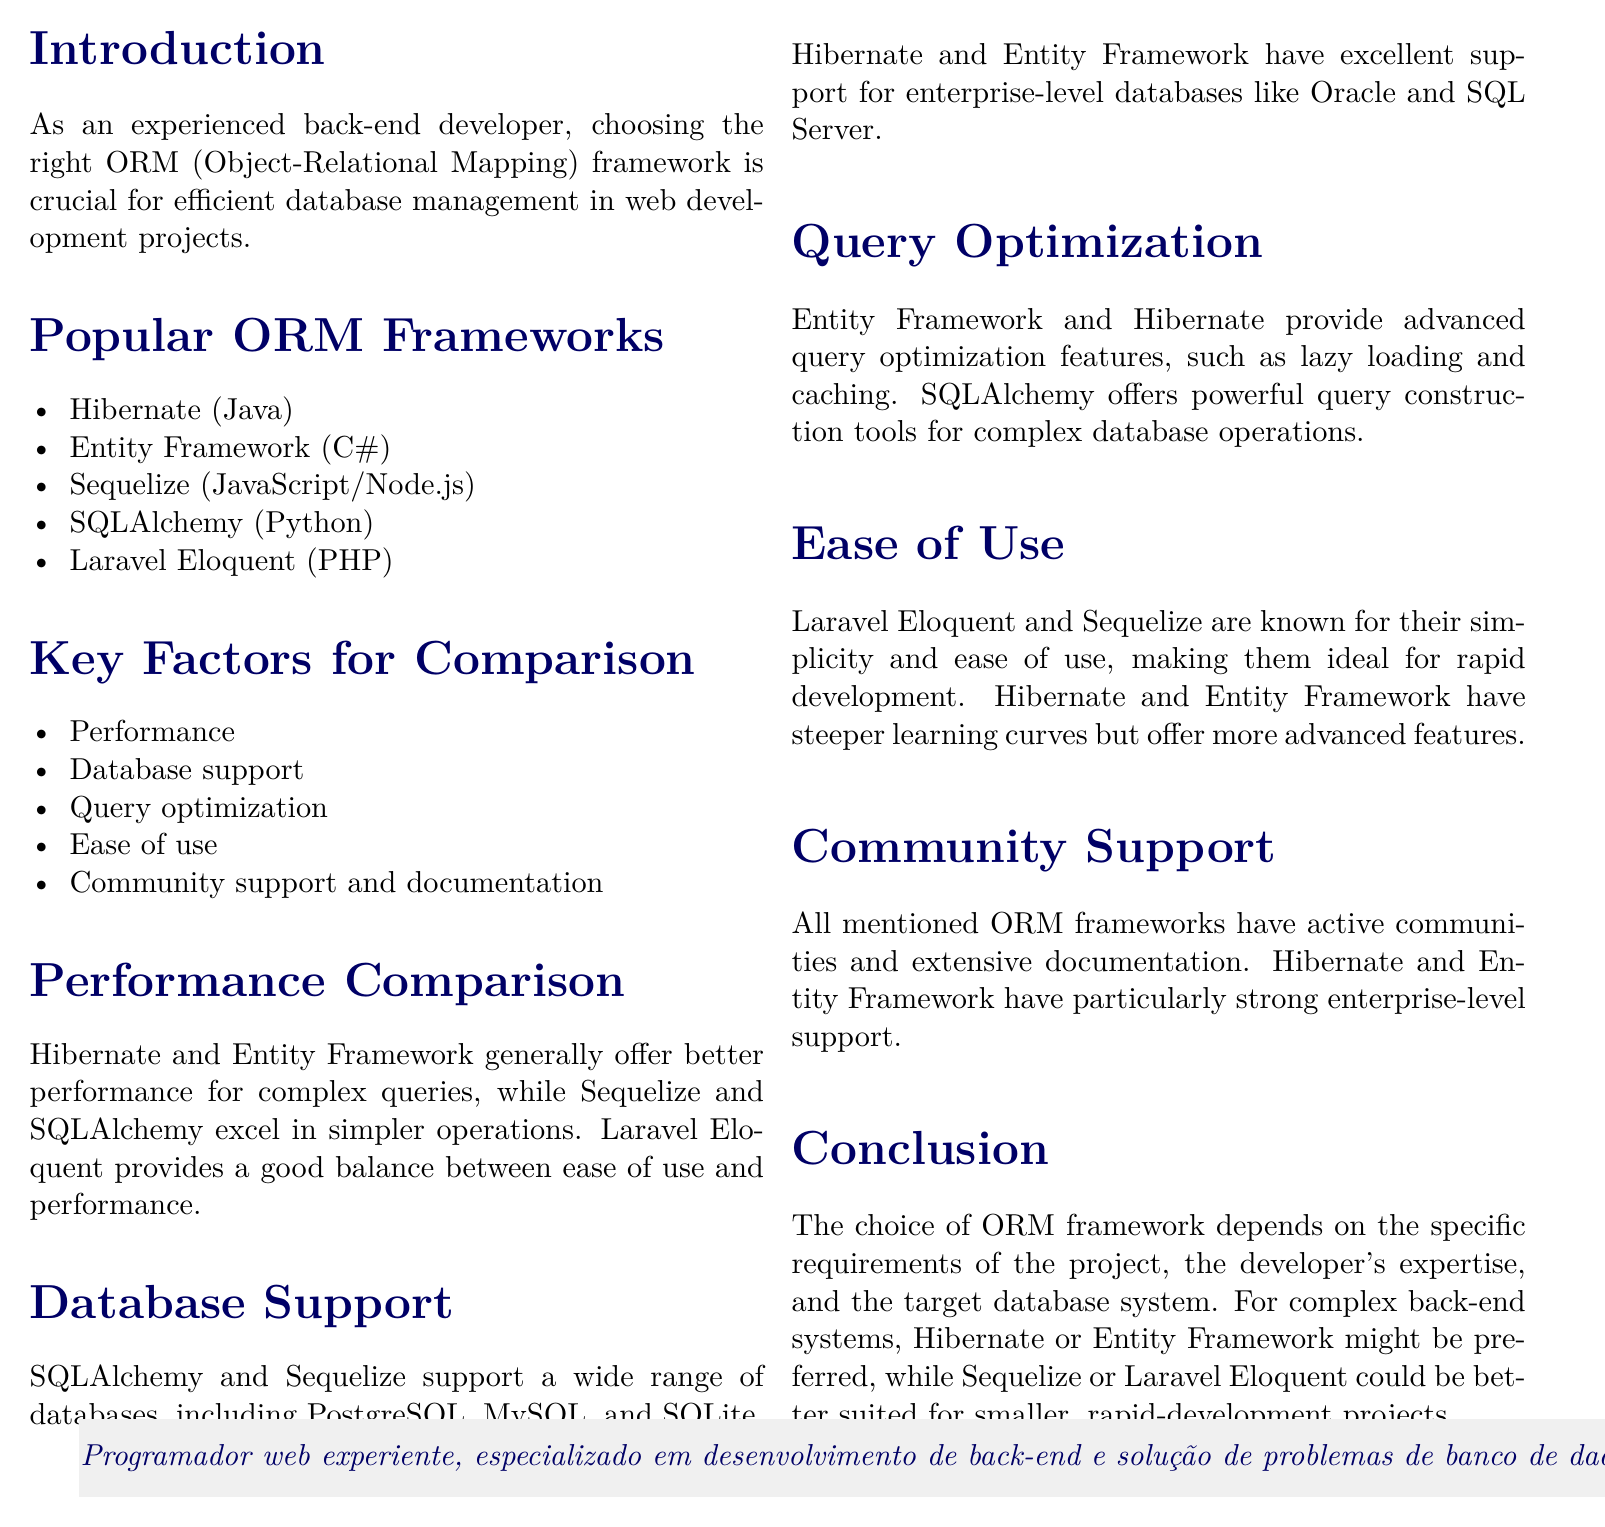What is the title of the document? The title of the document is stated at the beginning, summarizing the main topic of the notes.
Answer: Comparison of ORM Frameworks for Efficient Database Management in Web Development Which ORM framework is associated with Java? The document lists five popular ORM frameworks and specifies which language they are associated with, identifying Java's ORM framework.
Answer: Hibernate What key factor for comparison is focused on community support? The document outlines several factors for comparing ORM frameworks, one of which is specifically concerned with community engagement and resources available for developers.
Answer: Community support and documentation Which two frameworks provide better performance for complex queries? The performance comparison section indicates which frameworks excel in handling complex queries, highlighting their strengths.
Answer: Hibernate and Entity Framework What are two databases supported by SQLAlchemy? The document mentions that SQLAlchemy supports a variety of databases, and the answer can be found within the database support section.
Answer: PostgreSQL and MySQL Which ORM frameworks are ideal for rapid development? The ease of use section discusses frameworks suitable for quick development, identifying those known for simplicity.
Answer: Laravel Eloquent and Sequelize Do Hibernate and Entity Framework have a steep learning curve? This question refers to the ease of use section, where the learning requirements of various ORM frameworks are mentioned.
Answer: Yes What is one advanced query optimization feature of Entity Framework? The document describes features offered by ORM frameworks regarding query optimization, specifying distinctive capabilities attributed to Entity Framework.
Answer: Lazy loading 